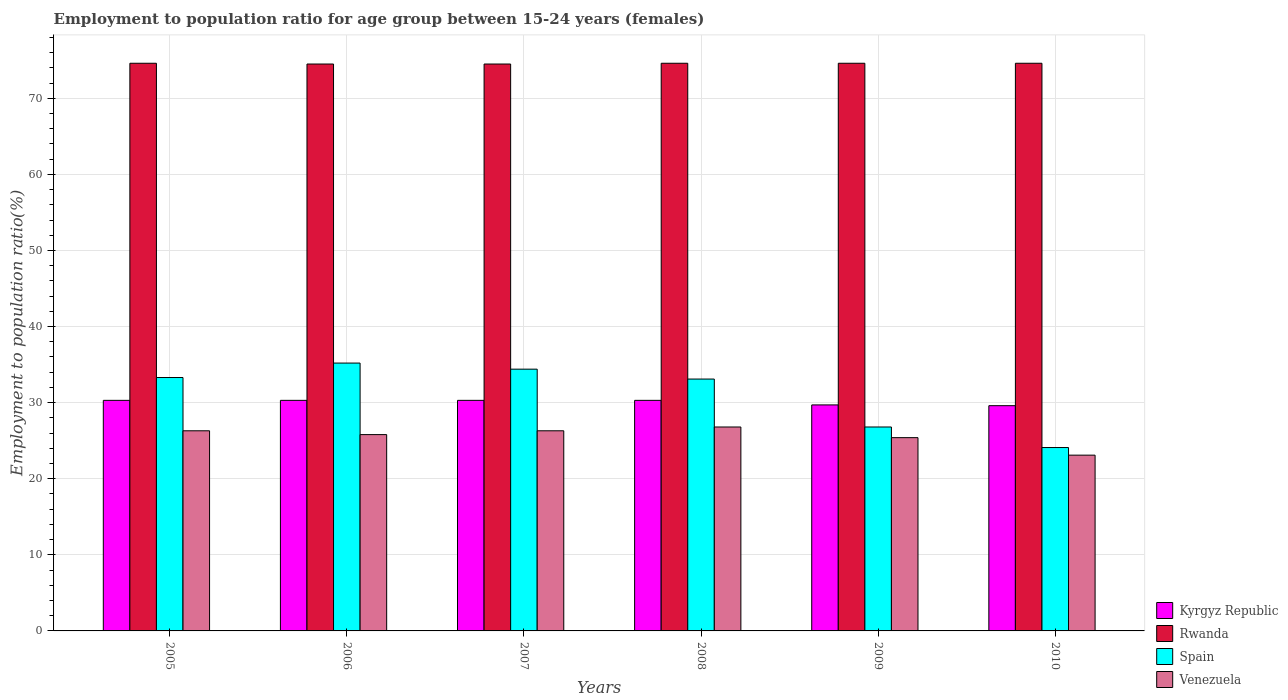How many different coloured bars are there?
Offer a terse response. 4. How many groups of bars are there?
Your answer should be very brief. 6. Are the number of bars per tick equal to the number of legend labels?
Keep it short and to the point. Yes. In how many cases, is the number of bars for a given year not equal to the number of legend labels?
Ensure brevity in your answer.  0. What is the employment to population ratio in Kyrgyz Republic in 2005?
Offer a terse response. 30.3. Across all years, what is the maximum employment to population ratio in Venezuela?
Offer a terse response. 26.8. Across all years, what is the minimum employment to population ratio in Rwanda?
Provide a short and direct response. 74.5. What is the total employment to population ratio in Venezuela in the graph?
Ensure brevity in your answer.  153.7. What is the difference between the employment to population ratio in Venezuela in 2008 and that in 2009?
Ensure brevity in your answer.  1.4. What is the difference between the employment to population ratio in Venezuela in 2009 and the employment to population ratio in Kyrgyz Republic in 2006?
Ensure brevity in your answer.  -4.9. What is the average employment to population ratio in Venezuela per year?
Ensure brevity in your answer.  25.62. In the year 2007, what is the difference between the employment to population ratio in Rwanda and employment to population ratio in Spain?
Provide a short and direct response. 40.1. What is the ratio of the employment to population ratio in Kyrgyz Republic in 2006 to that in 2010?
Keep it short and to the point. 1.02. Is the difference between the employment to population ratio in Rwanda in 2008 and 2009 greater than the difference between the employment to population ratio in Spain in 2008 and 2009?
Offer a very short reply. No. What is the difference between the highest and the second highest employment to population ratio in Venezuela?
Provide a short and direct response. 0.5. What is the difference between the highest and the lowest employment to population ratio in Spain?
Give a very brief answer. 11.1. In how many years, is the employment to population ratio in Venezuela greater than the average employment to population ratio in Venezuela taken over all years?
Make the answer very short. 4. Is the sum of the employment to population ratio in Venezuela in 2008 and 2009 greater than the maximum employment to population ratio in Rwanda across all years?
Give a very brief answer. No. What does the 4th bar from the left in 2005 represents?
Give a very brief answer. Venezuela. What does the 1st bar from the right in 2006 represents?
Keep it short and to the point. Venezuela. How many bars are there?
Provide a succinct answer. 24. Are all the bars in the graph horizontal?
Give a very brief answer. No. Are the values on the major ticks of Y-axis written in scientific E-notation?
Ensure brevity in your answer.  No. How many legend labels are there?
Give a very brief answer. 4. What is the title of the graph?
Your answer should be very brief. Employment to population ratio for age group between 15-24 years (females). What is the label or title of the Y-axis?
Make the answer very short. Employment to population ratio(%). What is the Employment to population ratio(%) in Kyrgyz Republic in 2005?
Ensure brevity in your answer.  30.3. What is the Employment to population ratio(%) in Rwanda in 2005?
Offer a terse response. 74.6. What is the Employment to population ratio(%) in Spain in 2005?
Your response must be concise. 33.3. What is the Employment to population ratio(%) in Venezuela in 2005?
Ensure brevity in your answer.  26.3. What is the Employment to population ratio(%) in Kyrgyz Republic in 2006?
Ensure brevity in your answer.  30.3. What is the Employment to population ratio(%) of Rwanda in 2006?
Your answer should be very brief. 74.5. What is the Employment to population ratio(%) in Spain in 2006?
Your answer should be very brief. 35.2. What is the Employment to population ratio(%) in Venezuela in 2006?
Your response must be concise. 25.8. What is the Employment to population ratio(%) in Kyrgyz Republic in 2007?
Ensure brevity in your answer.  30.3. What is the Employment to population ratio(%) of Rwanda in 2007?
Offer a terse response. 74.5. What is the Employment to population ratio(%) in Spain in 2007?
Keep it short and to the point. 34.4. What is the Employment to population ratio(%) of Venezuela in 2007?
Provide a succinct answer. 26.3. What is the Employment to population ratio(%) in Kyrgyz Republic in 2008?
Your answer should be compact. 30.3. What is the Employment to population ratio(%) in Rwanda in 2008?
Offer a terse response. 74.6. What is the Employment to population ratio(%) of Spain in 2008?
Provide a short and direct response. 33.1. What is the Employment to population ratio(%) in Venezuela in 2008?
Keep it short and to the point. 26.8. What is the Employment to population ratio(%) of Kyrgyz Republic in 2009?
Your answer should be very brief. 29.7. What is the Employment to population ratio(%) of Rwanda in 2009?
Offer a terse response. 74.6. What is the Employment to population ratio(%) of Spain in 2009?
Your response must be concise. 26.8. What is the Employment to population ratio(%) in Venezuela in 2009?
Offer a very short reply. 25.4. What is the Employment to population ratio(%) of Kyrgyz Republic in 2010?
Ensure brevity in your answer.  29.6. What is the Employment to population ratio(%) in Rwanda in 2010?
Give a very brief answer. 74.6. What is the Employment to population ratio(%) in Spain in 2010?
Ensure brevity in your answer.  24.1. What is the Employment to population ratio(%) in Venezuela in 2010?
Your answer should be compact. 23.1. Across all years, what is the maximum Employment to population ratio(%) of Kyrgyz Republic?
Provide a short and direct response. 30.3. Across all years, what is the maximum Employment to population ratio(%) of Rwanda?
Provide a short and direct response. 74.6. Across all years, what is the maximum Employment to population ratio(%) in Spain?
Provide a short and direct response. 35.2. Across all years, what is the maximum Employment to population ratio(%) in Venezuela?
Make the answer very short. 26.8. Across all years, what is the minimum Employment to population ratio(%) in Kyrgyz Republic?
Your answer should be very brief. 29.6. Across all years, what is the minimum Employment to population ratio(%) of Rwanda?
Make the answer very short. 74.5. Across all years, what is the minimum Employment to population ratio(%) in Spain?
Your response must be concise. 24.1. Across all years, what is the minimum Employment to population ratio(%) in Venezuela?
Make the answer very short. 23.1. What is the total Employment to population ratio(%) of Kyrgyz Republic in the graph?
Your answer should be very brief. 180.5. What is the total Employment to population ratio(%) of Rwanda in the graph?
Your response must be concise. 447.4. What is the total Employment to population ratio(%) of Spain in the graph?
Make the answer very short. 186.9. What is the total Employment to population ratio(%) of Venezuela in the graph?
Make the answer very short. 153.7. What is the difference between the Employment to population ratio(%) of Rwanda in 2005 and that in 2006?
Provide a succinct answer. 0.1. What is the difference between the Employment to population ratio(%) in Rwanda in 2005 and that in 2007?
Provide a short and direct response. 0.1. What is the difference between the Employment to population ratio(%) of Kyrgyz Republic in 2005 and that in 2008?
Provide a short and direct response. 0. What is the difference between the Employment to population ratio(%) in Rwanda in 2005 and that in 2008?
Keep it short and to the point. 0. What is the difference between the Employment to population ratio(%) of Spain in 2005 and that in 2008?
Give a very brief answer. 0.2. What is the difference between the Employment to population ratio(%) of Venezuela in 2005 and that in 2008?
Give a very brief answer. -0.5. What is the difference between the Employment to population ratio(%) of Rwanda in 2005 and that in 2009?
Ensure brevity in your answer.  0. What is the difference between the Employment to population ratio(%) of Spain in 2005 and that in 2009?
Keep it short and to the point. 6.5. What is the difference between the Employment to population ratio(%) in Kyrgyz Republic in 2006 and that in 2007?
Give a very brief answer. 0. What is the difference between the Employment to population ratio(%) of Spain in 2006 and that in 2007?
Provide a succinct answer. 0.8. What is the difference between the Employment to population ratio(%) in Venezuela in 2006 and that in 2007?
Give a very brief answer. -0.5. What is the difference between the Employment to population ratio(%) in Rwanda in 2006 and that in 2008?
Provide a succinct answer. -0.1. What is the difference between the Employment to population ratio(%) of Venezuela in 2006 and that in 2008?
Give a very brief answer. -1. What is the difference between the Employment to population ratio(%) of Venezuela in 2006 and that in 2009?
Provide a short and direct response. 0.4. What is the difference between the Employment to population ratio(%) of Venezuela in 2006 and that in 2010?
Your response must be concise. 2.7. What is the difference between the Employment to population ratio(%) in Spain in 2007 and that in 2008?
Your response must be concise. 1.3. What is the difference between the Employment to population ratio(%) in Venezuela in 2007 and that in 2008?
Provide a short and direct response. -0.5. What is the difference between the Employment to population ratio(%) in Spain in 2007 and that in 2010?
Make the answer very short. 10.3. What is the difference between the Employment to population ratio(%) of Kyrgyz Republic in 2008 and that in 2009?
Make the answer very short. 0.6. What is the difference between the Employment to population ratio(%) of Spain in 2008 and that in 2009?
Provide a short and direct response. 6.3. What is the difference between the Employment to population ratio(%) of Venezuela in 2008 and that in 2009?
Your answer should be very brief. 1.4. What is the difference between the Employment to population ratio(%) in Venezuela in 2008 and that in 2010?
Provide a succinct answer. 3.7. What is the difference between the Employment to population ratio(%) of Kyrgyz Republic in 2005 and the Employment to population ratio(%) of Rwanda in 2006?
Keep it short and to the point. -44.2. What is the difference between the Employment to population ratio(%) of Kyrgyz Republic in 2005 and the Employment to population ratio(%) of Venezuela in 2006?
Make the answer very short. 4.5. What is the difference between the Employment to population ratio(%) of Rwanda in 2005 and the Employment to population ratio(%) of Spain in 2006?
Your answer should be very brief. 39.4. What is the difference between the Employment to population ratio(%) in Rwanda in 2005 and the Employment to population ratio(%) in Venezuela in 2006?
Make the answer very short. 48.8. What is the difference between the Employment to population ratio(%) of Kyrgyz Republic in 2005 and the Employment to population ratio(%) of Rwanda in 2007?
Provide a short and direct response. -44.2. What is the difference between the Employment to population ratio(%) in Kyrgyz Republic in 2005 and the Employment to population ratio(%) in Spain in 2007?
Offer a terse response. -4.1. What is the difference between the Employment to population ratio(%) of Kyrgyz Republic in 2005 and the Employment to population ratio(%) of Venezuela in 2007?
Ensure brevity in your answer.  4. What is the difference between the Employment to population ratio(%) of Rwanda in 2005 and the Employment to population ratio(%) of Spain in 2007?
Provide a succinct answer. 40.2. What is the difference between the Employment to population ratio(%) of Rwanda in 2005 and the Employment to population ratio(%) of Venezuela in 2007?
Offer a terse response. 48.3. What is the difference between the Employment to population ratio(%) in Spain in 2005 and the Employment to population ratio(%) in Venezuela in 2007?
Your answer should be compact. 7. What is the difference between the Employment to population ratio(%) in Kyrgyz Republic in 2005 and the Employment to population ratio(%) in Rwanda in 2008?
Give a very brief answer. -44.3. What is the difference between the Employment to population ratio(%) in Rwanda in 2005 and the Employment to population ratio(%) in Spain in 2008?
Provide a succinct answer. 41.5. What is the difference between the Employment to population ratio(%) of Rwanda in 2005 and the Employment to population ratio(%) of Venezuela in 2008?
Provide a short and direct response. 47.8. What is the difference between the Employment to population ratio(%) of Kyrgyz Republic in 2005 and the Employment to population ratio(%) of Rwanda in 2009?
Provide a succinct answer. -44.3. What is the difference between the Employment to population ratio(%) in Kyrgyz Republic in 2005 and the Employment to population ratio(%) in Venezuela in 2009?
Ensure brevity in your answer.  4.9. What is the difference between the Employment to population ratio(%) of Rwanda in 2005 and the Employment to population ratio(%) of Spain in 2009?
Ensure brevity in your answer.  47.8. What is the difference between the Employment to population ratio(%) of Rwanda in 2005 and the Employment to population ratio(%) of Venezuela in 2009?
Give a very brief answer. 49.2. What is the difference between the Employment to population ratio(%) of Spain in 2005 and the Employment to population ratio(%) of Venezuela in 2009?
Offer a very short reply. 7.9. What is the difference between the Employment to population ratio(%) of Kyrgyz Republic in 2005 and the Employment to population ratio(%) of Rwanda in 2010?
Offer a very short reply. -44.3. What is the difference between the Employment to population ratio(%) in Rwanda in 2005 and the Employment to population ratio(%) in Spain in 2010?
Ensure brevity in your answer.  50.5. What is the difference between the Employment to population ratio(%) of Rwanda in 2005 and the Employment to population ratio(%) of Venezuela in 2010?
Your response must be concise. 51.5. What is the difference between the Employment to population ratio(%) in Kyrgyz Republic in 2006 and the Employment to population ratio(%) in Rwanda in 2007?
Your answer should be compact. -44.2. What is the difference between the Employment to population ratio(%) of Rwanda in 2006 and the Employment to population ratio(%) of Spain in 2007?
Your response must be concise. 40.1. What is the difference between the Employment to population ratio(%) of Rwanda in 2006 and the Employment to population ratio(%) of Venezuela in 2007?
Make the answer very short. 48.2. What is the difference between the Employment to population ratio(%) of Kyrgyz Republic in 2006 and the Employment to population ratio(%) of Rwanda in 2008?
Your response must be concise. -44.3. What is the difference between the Employment to population ratio(%) in Kyrgyz Republic in 2006 and the Employment to population ratio(%) in Venezuela in 2008?
Your response must be concise. 3.5. What is the difference between the Employment to population ratio(%) in Rwanda in 2006 and the Employment to population ratio(%) in Spain in 2008?
Offer a terse response. 41.4. What is the difference between the Employment to population ratio(%) of Rwanda in 2006 and the Employment to population ratio(%) of Venezuela in 2008?
Offer a terse response. 47.7. What is the difference between the Employment to population ratio(%) in Spain in 2006 and the Employment to population ratio(%) in Venezuela in 2008?
Your answer should be compact. 8.4. What is the difference between the Employment to population ratio(%) in Kyrgyz Republic in 2006 and the Employment to population ratio(%) in Rwanda in 2009?
Keep it short and to the point. -44.3. What is the difference between the Employment to population ratio(%) in Kyrgyz Republic in 2006 and the Employment to population ratio(%) in Venezuela in 2009?
Give a very brief answer. 4.9. What is the difference between the Employment to population ratio(%) in Rwanda in 2006 and the Employment to population ratio(%) in Spain in 2009?
Your response must be concise. 47.7. What is the difference between the Employment to population ratio(%) of Rwanda in 2006 and the Employment to population ratio(%) of Venezuela in 2009?
Give a very brief answer. 49.1. What is the difference between the Employment to population ratio(%) of Spain in 2006 and the Employment to population ratio(%) of Venezuela in 2009?
Keep it short and to the point. 9.8. What is the difference between the Employment to population ratio(%) of Kyrgyz Republic in 2006 and the Employment to population ratio(%) of Rwanda in 2010?
Make the answer very short. -44.3. What is the difference between the Employment to population ratio(%) in Kyrgyz Republic in 2006 and the Employment to population ratio(%) in Spain in 2010?
Ensure brevity in your answer.  6.2. What is the difference between the Employment to population ratio(%) in Kyrgyz Republic in 2006 and the Employment to population ratio(%) in Venezuela in 2010?
Keep it short and to the point. 7.2. What is the difference between the Employment to population ratio(%) in Rwanda in 2006 and the Employment to population ratio(%) in Spain in 2010?
Your response must be concise. 50.4. What is the difference between the Employment to population ratio(%) in Rwanda in 2006 and the Employment to population ratio(%) in Venezuela in 2010?
Give a very brief answer. 51.4. What is the difference between the Employment to population ratio(%) in Spain in 2006 and the Employment to population ratio(%) in Venezuela in 2010?
Your answer should be very brief. 12.1. What is the difference between the Employment to population ratio(%) of Kyrgyz Republic in 2007 and the Employment to population ratio(%) of Rwanda in 2008?
Your response must be concise. -44.3. What is the difference between the Employment to population ratio(%) of Kyrgyz Republic in 2007 and the Employment to population ratio(%) of Venezuela in 2008?
Keep it short and to the point. 3.5. What is the difference between the Employment to population ratio(%) of Rwanda in 2007 and the Employment to population ratio(%) of Spain in 2008?
Ensure brevity in your answer.  41.4. What is the difference between the Employment to population ratio(%) of Rwanda in 2007 and the Employment to population ratio(%) of Venezuela in 2008?
Your response must be concise. 47.7. What is the difference between the Employment to population ratio(%) in Kyrgyz Republic in 2007 and the Employment to population ratio(%) in Rwanda in 2009?
Give a very brief answer. -44.3. What is the difference between the Employment to population ratio(%) of Kyrgyz Republic in 2007 and the Employment to population ratio(%) of Spain in 2009?
Your answer should be compact. 3.5. What is the difference between the Employment to population ratio(%) of Kyrgyz Republic in 2007 and the Employment to population ratio(%) of Venezuela in 2009?
Your response must be concise. 4.9. What is the difference between the Employment to population ratio(%) in Rwanda in 2007 and the Employment to population ratio(%) in Spain in 2009?
Make the answer very short. 47.7. What is the difference between the Employment to population ratio(%) of Rwanda in 2007 and the Employment to population ratio(%) of Venezuela in 2009?
Offer a very short reply. 49.1. What is the difference between the Employment to population ratio(%) in Spain in 2007 and the Employment to population ratio(%) in Venezuela in 2009?
Your answer should be compact. 9. What is the difference between the Employment to population ratio(%) in Kyrgyz Republic in 2007 and the Employment to population ratio(%) in Rwanda in 2010?
Your answer should be compact. -44.3. What is the difference between the Employment to population ratio(%) of Rwanda in 2007 and the Employment to population ratio(%) of Spain in 2010?
Offer a very short reply. 50.4. What is the difference between the Employment to population ratio(%) of Rwanda in 2007 and the Employment to population ratio(%) of Venezuela in 2010?
Your response must be concise. 51.4. What is the difference between the Employment to population ratio(%) in Kyrgyz Republic in 2008 and the Employment to population ratio(%) in Rwanda in 2009?
Keep it short and to the point. -44.3. What is the difference between the Employment to population ratio(%) of Rwanda in 2008 and the Employment to population ratio(%) of Spain in 2009?
Provide a short and direct response. 47.8. What is the difference between the Employment to population ratio(%) of Rwanda in 2008 and the Employment to population ratio(%) of Venezuela in 2009?
Offer a terse response. 49.2. What is the difference between the Employment to population ratio(%) of Spain in 2008 and the Employment to population ratio(%) of Venezuela in 2009?
Make the answer very short. 7.7. What is the difference between the Employment to population ratio(%) in Kyrgyz Republic in 2008 and the Employment to population ratio(%) in Rwanda in 2010?
Provide a succinct answer. -44.3. What is the difference between the Employment to population ratio(%) of Rwanda in 2008 and the Employment to population ratio(%) of Spain in 2010?
Make the answer very short. 50.5. What is the difference between the Employment to population ratio(%) of Rwanda in 2008 and the Employment to population ratio(%) of Venezuela in 2010?
Provide a short and direct response. 51.5. What is the difference between the Employment to population ratio(%) in Spain in 2008 and the Employment to population ratio(%) in Venezuela in 2010?
Offer a very short reply. 10. What is the difference between the Employment to population ratio(%) of Kyrgyz Republic in 2009 and the Employment to population ratio(%) of Rwanda in 2010?
Your answer should be very brief. -44.9. What is the difference between the Employment to population ratio(%) in Kyrgyz Republic in 2009 and the Employment to population ratio(%) in Spain in 2010?
Your answer should be very brief. 5.6. What is the difference between the Employment to population ratio(%) in Kyrgyz Republic in 2009 and the Employment to population ratio(%) in Venezuela in 2010?
Your answer should be compact. 6.6. What is the difference between the Employment to population ratio(%) in Rwanda in 2009 and the Employment to population ratio(%) in Spain in 2010?
Provide a short and direct response. 50.5. What is the difference between the Employment to population ratio(%) of Rwanda in 2009 and the Employment to population ratio(%) of Venezuela in 2010?
Offer a very short reply. 51.5. What is the average Employment to population ratio(%) of Kyrgyz Republic per year?
Your answer should be compact. 30.08. What is the average Employment to population ratio(%) of Rwanda per year?
Offer a terse response. 74.57. What is the average Employment to population ratio(%) of Spain per year?
Keep it short and to the point. 31.15. What is the average Employment to population ratio(%) in Venezuela per year?
Offer a terse response. 25.62. In the year 2005, what is the difference between the Employment to population ratio(%) in Kyrgyz Republic and Employment to population ratio(%) in Rwanda?
Make the answer very short. -44.3. In the year 2005, what is the difference between the Employment to population ratio(%) in Kyrgyz Republic and Employment to population ratio(%) in Venezuela?
Keep it short and to the point. 4. In the year 2005, what is the difference between the Employment to population ratio(%) in Rwanda and Employment to population ratio(%) in Spain?
Provide a succinct answer. 41.3. In the year 2005, what is the difference between the Employment to population ratio(%) of Rwanda and Employment to population ratio(%) of Venezuela?
Keep it short and to the point. 48.3. In the year 2005, what is the difference between the Employment to population ratio(%) of Spain and Employment to population ratio(%) of Venezuela?
Make the answer very short. 7. In the year 2006, what is the difference between the Employment to population ratio(%) of Kyrgyz Republic and Employment to population ratio(%) of Rwanda?
Make the answer very short. -44.2. In the year 2006, what is the difference between the Employment to population ratio(%) in Rwanda and Employment to population ratio(%) in Spain?
Provide a succinct answer. 39.3. In the year 2006, what is the difference between the Employment to population ratio(%) in Rwanda and Employment to population ratio(%) in Venezuela?
Offer a very short reply. 48.7. In the year 2007, what is the difference between the Employment to population ratio(%) of Kyrgyz Republic and Employment to population ratio(%) of Rwanda?
Your response must be concise. -44.2. In the year 2007, what is the difference between the Employment to population ratio(%) in Kyrgyz Republic and Employment to population ratio(%) in Spain?
Make the answer very short. -4.1. In the year 2007, what is the difference between the Employment to population ratio(%) of Kyrgyz Republic and Employment to population ratio(%) of Venezuela?
Your answer should be compact. 4. In the year 2007, what is the difference between the Employment to population ratio(%) of Rwanda and Employment to population ratio(%) of Spain?
Your answer should be very brief. 40.1. In the year 2007, what is the difference between the Employment to population ratio(%) of Rwanda and Employment to population ratio(%) of Venezuela?
Keep it short and to the point. 48.2. In the year 2008, what is the difference between the Employment to population ratio(%) in Kyrgyz Republic and Employment to population ratio(%) in Rwanda?
Offer a very short reply. -44.3. In the year 2008, what is the difference between the Employment to population ratio(%) in Kyrgyz Republic and Employment to population ratio(%) in Venezuela?
Your response must be concise. 3.5. In the year 2008, what is the difference between the Employment to population ratio(%) in Rwanda and Employment to population ratio(%) in Spain?
Keep it short and to the point. 41.5. In the year 2008, what is the difference between the Employment to population ratio(%) in Rwanda and Employment to population ratio(%) in Venezuela?
Keep it short and to the point. 47.8. In the year 2009, what is the difference between the Employment to population ratio(%) in Kyrgyz Republic and Employment to population ratio(%) in Rwanda?
Provide a short and direct response. -44.9. In the year 2009, what is the difference between the Employment to population ratio(%) of Kyrgyz Republic and Employment to population ratio(%) of Spain?
Your response must be concise. 2.9. In the year 2009, what is the difference between the Employment to population ratio(%) of Kyrgyz Republic and Employment to population ratio(%) of Venezuela?
Your response must be concise. 4.3. In the year 2009, what is the difference between the Employment to population ratio(%) of Rwanda and Employment to population ratio(%) of Spain?
Ensure brevity in your answer.  47.8. In the year 2009, what is the difference between the Employment to population ratio(%) of Rwanda and Employment to population ratio(%) of Venezuela?
Offer a terse response. 49.2. In the year 2010, what is the difference between the Employment to population ratio(%) in Kyrgyz Republic and Employment to population ratio(%) in Rwanda?
Your answer should be compact. -45. In the year 2010, what is the difference between the Employment to population ratio(%) of Kyrgyz Republic and Employment to population ratio(%) of Spain?
Your answer should be compact. 5.5. In the year 2010, what is the difference between the Employment to population ratio(%) in Rwanda and Employment to population ratio(%) in Spain?
Offer a terse response. 50.5. In the year 2010, what is the difference between the Employment to population ratio(%) in Rwanda and Employment to population ratio(%) in Venezuela?
Give a very brief answer. 51.5. What is the ratio of the Employment to population ratio(%) of Spain in 2005 to that in 2006?
Your response must be concise. 0.95. What is the ratio of the Employment to population ratio(%) of Venezuela in 2005 to that in 2006?
Make the answer very short. 1.02. What is the ratio of the Employment to population ratio(%) in Kyrgyz Republic in 2005 to that in 2007?
Keep it short and to the point. 1. What is the ratio of the Employment to population ratio(%) in Spain in 2005 to that in 2007?
Your answer should be very brief. 0.97. What is the ratio of the Employment to population ratio(%) in Kyrgyz Republic in 2005 to that in 2008?
Your answer should be compact. 1. What is the ratio of the Employment to population ratio(%) of Spain in 2005 to that in 2008?
Offer a very short reply. 1.01. What is the ratio of the Employment to population ratio(%) of Venezuela in 2005 to that in 2008?
Provide a short and direct response. 0.98. What is the ratio of the Employment to population ratio(%) in Kyrgyz Republic in 2005 to that in 2009?
Provide a short and direct response. 1.02. What is the ratio of the Employment to population ratio(%) of Rwanda in 2005 to that in 2009?
Keep it short and to the point. 1. What is the ratio of the Employment to population ratio(%) in Spain in 2005 to that in 2009?
Your response must be concise. 1.24. What is the ratio of the Employment to population ratio(%) of Venezuela in 2005 to that in 2009?
Offer a very short reply. 1.04. What is the ratio of the Employment to population ratio(%) in Kyrgyz Republic in 2005 to that in 2010?
Keep it short and to the point. 1.02. What is the ratio of the Employment to population ratio(%) of Rwanda in 2005 to that in 2010?
Offer a terse response. 1. What is the ratio of the Employment to population ratio(%) of Spain in 2005 to that in 2010?
Make the answer very short. 1.38. What is the ratio of the Employment to population ratio(%) in Venezuela in 2005 to that in 2010?
Provide a short and direct response. 1.14. What is the ratio of the Employment to population ratio(%) of Kyrgyz Republic in 2006 to that in 2007?
Ensure brevity in your answer.  1. What is the ratio of the Employment to population ratio(%) of Spain in 2006 to that in 2007?
Ensure brevity in your answer.  1.02. What is the ratio of the Employment to population ratio(%) of Rwanda in 2006 to that in 2008?
Offer a very short reply. 1. What is the ratio of the Employment to population ratio(%) in Spain in 2006 to that in 2008?
Provide a short and direct response. 1.06. What is the ratio of the Employment to population ratio(%) in Venezuela in 2006 to that in 2008?
Offer a terse response. 0.96. What is the ratio of the Employment to population ratio(%) of Kyrgyz Republic in 2006 to that in 2009?
Your answer should be compact. 1.02. What is the ratio of the Employment to population ratio(%) in Spain in 2006 to that in 2009?
Provide a succinct answer. 1.31. What is the ratio of the Employment to population ratio(%) in Venezuela in 2006 to that in 2009?
Provide a short and direct response. 1.02. What is the ratio of the Employment to population ratio(%) of Kyrgyz Republic in 2006 to that in 2010?
Offer a very short reply. 1.02. What is the ratio of the Employment to population ratio(%) in Spain in 2006 to that in 2010?
Make the answer very short. 1.46. What is the ratio of the Employment to population ratio(%) of Venezuela in 2006 to that in 2010?
Give a very brief answer. 1.12. What is the ratio of the Employment to population ratio(%) in Kyrgyz Republic in 2007 to that in 2008?
Your answer should be very brief. 1. What is the ratio of the Employment to population ratio(%) of Rwanda in 2007 to that in 2008?
Your response must be concise. 1. What is the ratio of the Employment to population ratio(%) in Spain in 2007 to that in 2008?
Offer a terse response. 1.04. What is the ratio of the Employment to population ratio(%) in Venezuela in 2007 to that in 2008?
Your answer should be very brief. 0.98. What is the ratio of the Employment to population ratio(%) of Kyrgyz Republic in 2007 to that in 2009?
Offer a terse response. 1.02. What is the ratio of the Employment to population ratio(%) in Rwanda in 2007 to that in 2009?
Your response must be concise. 1. What is the ratio of the Employment to population ratio(%) of Spain in 2007 to that in 2009?
Offer a terse response. 1.28. What is the ratio of the Employment to population ratio(%) in Venezuela in 2007 to that in 2009?
Keep it short and to the point. 1.04. What is the ratio of the Employment to population ratio(%) of Kyrgyz Republic in 2007 to that in 2010?
Ensure brevity in your answer.  1.02. What is the ratio of the Employment to population ratio(%) in Spain in 2007 to that in 2010?
Offer a very short reply. 1.43. What is the ratio of the Employment to population ratio(%) in Venezuela in 2007 to that in 2010?
Your answer should be compact. 1.14. What is the ratio of the Employment to population ratio(%) of Kyrgyz Republic in 2008 to that in 2009?
Give a very brief answer. 1.02. What is the ratio of the Employment to population ratio(%) of Spain in 2008 to that in 2009?
Give a very brief answer. 1.24. What is the ratio of the Employment to population ratio(%) in Venezuela in 2008 to that in 2009?
Offer a terse response. 1.06. What is the ratio of the Employment to population ratio(%) in Kyrgyz Republic in 2008 to that in 2010?
Your response must be concise. 1.02. What is the ratio of the Employment to population ratio(%) of Spain in 2008 to that in 2010?
Your answer should be compact. 1.37. What is the ratio of the Employment to population ratio(%) of Venezuela in 2008 to that in 2010?
Your answer should be very brief. 1.16. What is the ratio of the Employment to population ratio(%) of Kyrgyz Republic in 2009 to that in 2010?
Your response must be concise. 1. What is the ratio of the Employment to population ratio(%) in Rwanda in 2009 to that in 2010?
Offer a terse response. 1. What is the ratio of the Employment to population ratio(%) in Spain in 2009 to that in 2010?
Your answer should be very brief. 1.11. What is the ratio of the Employment to population ratio(%) of Venezuela in 2009 to that in 2010?
Provide a succinct answer. 1.1. What is the difference between the highest and the second highest Employment to population ratio(%) in Spain?
Ensure brevity in your answer.  0.8. What is the difference between the highest and the lowest Employment to population ratio(%) in Kyrgyz Republic?
Ensure brevity in your answer.  0.7. What is the difference between the highest and the lowest Employment to population ratio(%) in Rwanda?
Provide a succinct answer. 0.1. What is the difference between the highest and the lowest Employment to population ratio(%) of Spain?
Provide a short and direct response. 11.1. What is the difference between the highest and the lowest Employment to population ratio(%) of Venezuela?
Your response must be concise. 3.7. 